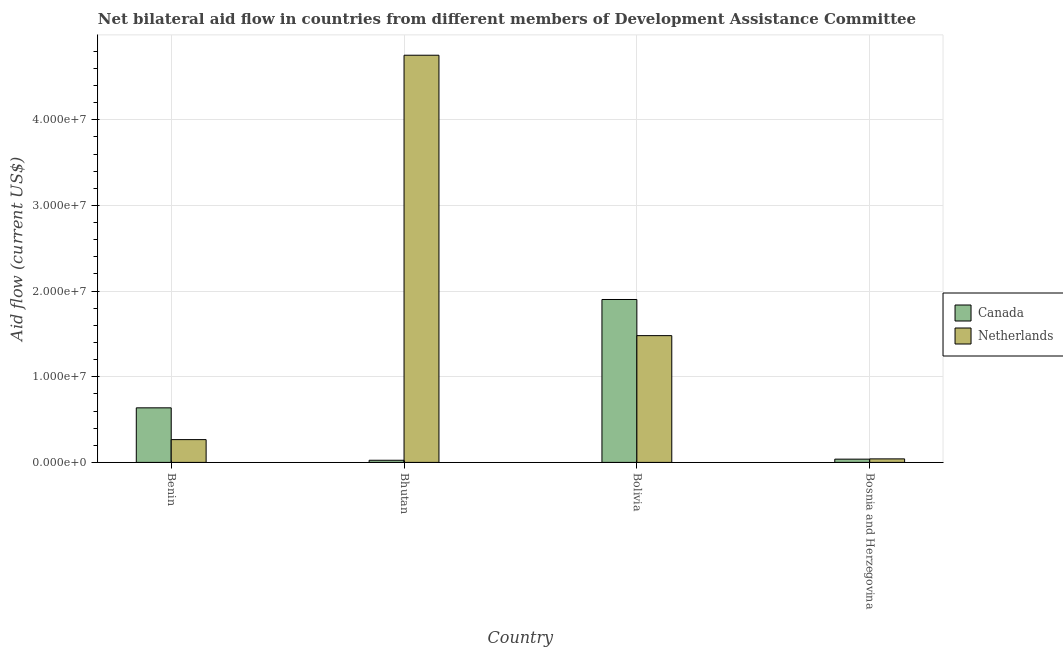Are the number of bars per tick equal to the number of legend labels?
Provide a succinct answer. Yes. How many bars are there on the 4th tick from the left?
Your answer should be compact. 2. What is the label of the 2nd group of bars from the left?
Your answer should be very brief. Bhutan. What is the amount of aid given by netherlands in Bosnia and Herzegovina?
Your answer should be very brief. 4.10e+05. Across all countries, what is the maximum amount of aid given by netherlands?
Offer a terse response. 4.75e+07. Across all countries, what is the minimum amount of aid given by netherlands?
Keep it short and to the point. 4.10e+05. In which country was the amount of aid given by netherlands maximum?
Make the answer very short. Bhutan. In which country was the amount of aid given by netherlands minimum?
Provide a short and direct response. Bosnia and Herzegovina. What is the total amount of aid given by netherlands in the graph?
Give a very brief answer. 6.54e+07. What is the difference between the amount of aid given by netherlands in Bhutan and that in Bosnia and Herzegovina?
Offer a terse response. 4.71e+07. What is the difference between the amount of aid given by netherlands in Bolivia and the amount of aid given by canada in Bosnia and Herzegovina?
Provide a succinct answer. 1.44e+07. What is the average amount of aid given by netherlands per country?
Offer a terse response. 1.64e+07. What is the difference between the amount of aid given by canada and amount of aid given by netherlands in Benin?
Ensure brevity in your answer.  3.71e+06. What is the ratio of the amount of aid given by canada in Bhutan to that in Bolivia?
Give a very brief answer. 0.01. Is the amount of aid given by canada in Bhutan less than that in Bosnia and Herzegovina?
Your response must be concise. Yes. What is the difference between the highest and the second highest amount of aid given by netherlands?
Your answer should be very brief. 3.27e+07. What is the difference between the highest and the lowest amount of aid given by canada?
Offer a terse response. 1.88e+07. Is the sum of the amount of aid given by netherlands in Benin and Bosnia and Herzegovina greater than the maximum amount of aid given by canada across all countries?
Offer a terse response. No. What does the 1st bar from the right in Bosnia and Herzegovina represents?
Your answer should be compact. Netherlands. What is the difference between two consecutive major ticks on the Y-axis?
Make the answer very short. 1.00e+07. Does the graph contain any zero values?
Make the answer very short. No. Where does the legend appear in the graph?
Your answer should be compact. Center right. How many legend labels are there?
Provide a short and direct response. 2. How are the legend labels stacked?
Your answer should be compact. Vertical. What is the title of the graph?
Your response must be concise. Net bilateral aid flow in countries from different members of Development Assistance Committee. Does "Underweight" appear as one of the legend labels in the graph?
Provide a short and direct response. No. What is the Aid flow (current US$) of Canada in Benin?
Provide a succinct answer. 6.37e+06. What is the Aid flow (current US$) in Netherlands in Benin?
Offer a very short reply. 2.66e+06. What is the Aid flow (current US$) of Canada in Bhutan?
Ensure brevity in your answer.  2.50e+05. What is the Aid flow (current US$) in Netherlands in Bhutan?
Provide a short and direct response. 4.75e+07. What is the Aid flow (current US$) in Canada in Bolivia?
Give a very brief answer. 1.90e+07. What is the Aid flow (current US$) in Netherlands in Bolivia?
Your answer should be compact. 1.48e+07. What is the Aid flow (current US$) of Canada in Bosnia and Herzegovina?
Provide a short and direct response. 3.80e+05. What is the Aid flow (current US$) of Netherlands in Bosnia and Herzegovina?
Offer a very short reply. 4.10e+05. Across all countries, what is the maximum Aid flow (current US$) in Canada?
Make the answer very short. 1.90e+07. Across all countries, what is the maximum Aid flow (current US$) of Netherlands?
Make the answer very short. 4.75e+07. Across all countries, what is the minimum Aid flow (current US$) of Canada?
Your response must be concise. 2.50e+05. What is the total Aid flow (current US$) in Canada in the graph?
Your answer should be compact. 2.60e+07. What is the total Aid flow (current US$) in Netherlands in the graph?
Your answer should be compact. 6.54e+07. What is the difference between the Aid flow (current US$) of Canada in Benin and that in Bhutan?
Provide a short and direct response. 6.12e+06. What is the difference between the Aid flow (current US$) of Netherlands in Benin and that in Bhutan?
Give a very brief answer. -4.49e+07. What is the difference between the Aid flow (current US$) of Canada in Benin and that in Bolivia?
Your response must be concise. -1.26e+07. What is the difference between the Aid flow (current US$) in Netherlands in Benin and that in Bolivia?
Offer a terse response. -1.21e+07. What is the difference between the Aid flow (current US$) of Canada in Benin and that in Bosnia and Herzegovina?
Ensure brevity in your answer.  5.99e+06. What is the difference between the Aid flow (current US$) of Netherlands in Benin and that in Bosnia and Herzegovina?
Provide a short and direct response. 2.25e+06. What is the difference between the Aid flow (current US$) in Canada in Bhutan and that in Bolivia?
Offer a terse response. -1.88e+07. What is the difference between the Aid flow (current US$) of Netherlands in Bhutan and that in Bolivia?
Provide a short and direct response. 3.27e+07. What is the difference between the Aid flow (current US$) in Canada in Bhutan and that in Bosnia and Herzegovina?
Offer a terse response. -1.30e+05. What is the difference between the Aid flow (current US$) in Netherlands in Bhutan and that in Bosnia and Herzegovina?
Provide a succinct answer. 4.71e+07. What is the difference between the Aid flow (current US$) in Canada in Bolivia and that in Bosnia and Herzegovina?
Offer a terse response. 1.86e+07. What is the difference between the Aid flow (current US$) of Netherlands in Bolivia and that in Bosnia and Herzegovina?
Make the answer very short. 1.44e+07. What is the difference between the Aid flow (current US$) in Canada in Benin and the Aid flow (current US$) in Netherlands in Bhutan?
Offer a very short reply. -4.12e+07. What is the difference between the Aid flow (current US$) in Canada in Benin and the Aid flow (current US$) in Netherlands in Bolivia?
Your answer should be compact. -8.43e+06. What is the difference between the Aid flow (current US$) in Canada in Benin and the Aid flow (current US$) in Netherlands in Bosnia and Herzegovina?
Offer a very short reply. 5.96e+06. What is the difference between the Aid flow (current US$) in Canada in Bhutan and the Aid flow (current US$) in Netherlands in Bolivia?
Offer a very short reply. -1.46e+07. What is the difference between the Aid flow (current US$) in Canada in Bolivia and the Aid flow (current US$) in Netherlands in Bosnia and Herzegovina?
Your response must be concise. 1.86e+07. What is the average Aid flow (current US$) in Canada per country?
Provide a succinct answer. 6.50e+06. What is the average Aid flow (current US$) in Netherlands per country?
Your response must be concise. 1.64e+07. What is the difference between the Aid flow (current US$) in Canada and Aid flow (current US$) in Netherlands in Benin?
Offer a terse response. 3.71e+06. What is the difference between the Aid flow (current US$) in Canada and Aid flow (current US$) in Netherlands in Bhutan?
Make the answer very short. -4.73e+07. What is the difference between the Aid flow (current US$) in Canada and Aid flow (current US$) in Netherlands in Bolivia?
Keep it short and to the point. 4.22e+06. What is the ratio of the Aid flow (current US$) of Canada in Benin to that in Bhutan?
Your answer should be very brief. 25.48. What is the ratio of the Aid flow (current US$) in Netherlands in Benin to that in Bhutan?
Offer a terse response. 0.06. What is the ratio of the Aid flow (current US$) in Canada in Benin to that in Bolivia?
Give a very brief answer. 0.33. What is the ratio of the Aid flow (current US$) in Netherlands in Benin to that in Bolivia?
Keep it short and to the point. 0.18. What is the ratio of the Aid flow (current US$) of Canada in Benin to that in Bosnia and Herzegovina?
Your answer should be very brief. 16.76. What is the ratio of the Aid flow (current US$) of Netherlands in Benin to that in Bosnia and Herzegovina?
Your answer should be compact. 6.49. What is the ratio of the Aid flow (current US$) in Canada in Bhutan to that in Bolivia?
Provide a short and direct response. 0.01. What is the ratio of the Aid flow (current US$) in Netherlands in Bhutan to that in Bolivia?
Ensure brevity in your answer.  3.21. What is the ratio of the Aid flow (current US$) in Canada in Bhutan to that in Bosnia and Herzegovina?
Provide a short and direct response. 0.66. What is the ratio of the Aid flow (current US$) in Netherlands in Bhutan to that in Bosnia and Herzegovina?
Provide a short and direct response. 115.95. What is the ratio of the Aid flow (current US$) of Canada in Bolivia to that in Bosnia and Herzegovina?
Make the answer very short. 50.05. What is the ratio of the Aid flow (current US$) of Netherlands in Bolivia to that in Bosnia and Herzegovina?
Offer a very short reply. 36.1. What is the difference between the highest and the second highest Aid flow (current US$) of Canada?
Your answer should be very brief. 1.26e+07. What is the difference between the highest and the second highest Aid flow (current US$) in Netherlands?
Provide a short and direct response. 3.27e+07. What is the difference between the highest and the lowest Aid flow (current US$) in Canada?
Your response must be concise. 1.88e+07. What is the difference between the highest and the lowest Aid flow (current US$) of Netherlands?
Provide a short and direct response. 4.71e+07. 